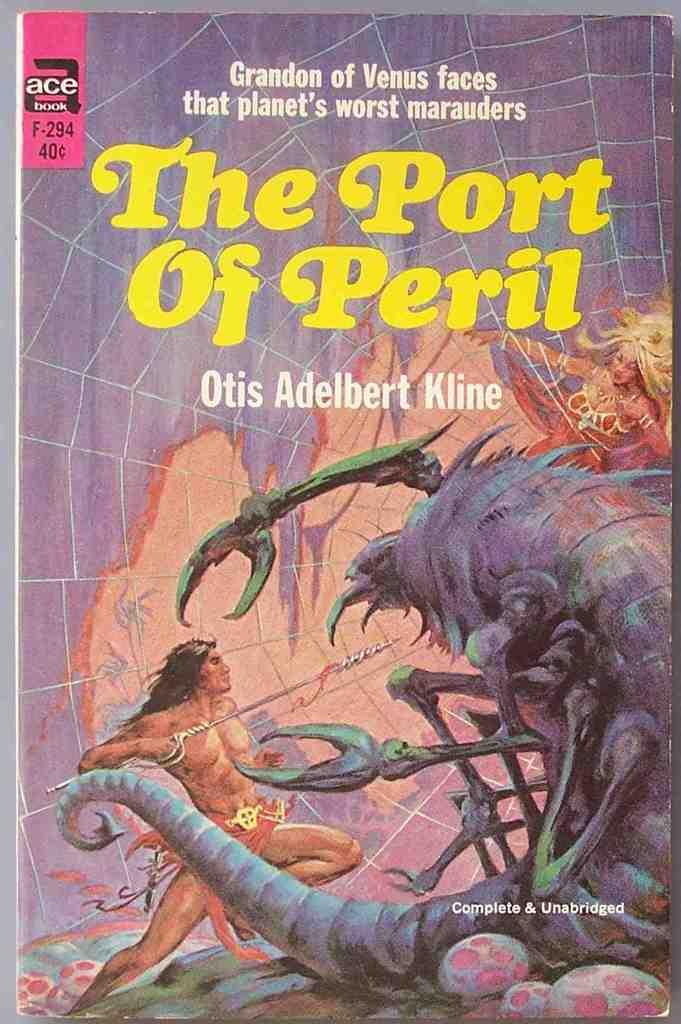<image>
Share a concise interpretation of the image provided. An Ace paperback book by Otis Adelbert Kline bears the title The Port of Peril. 